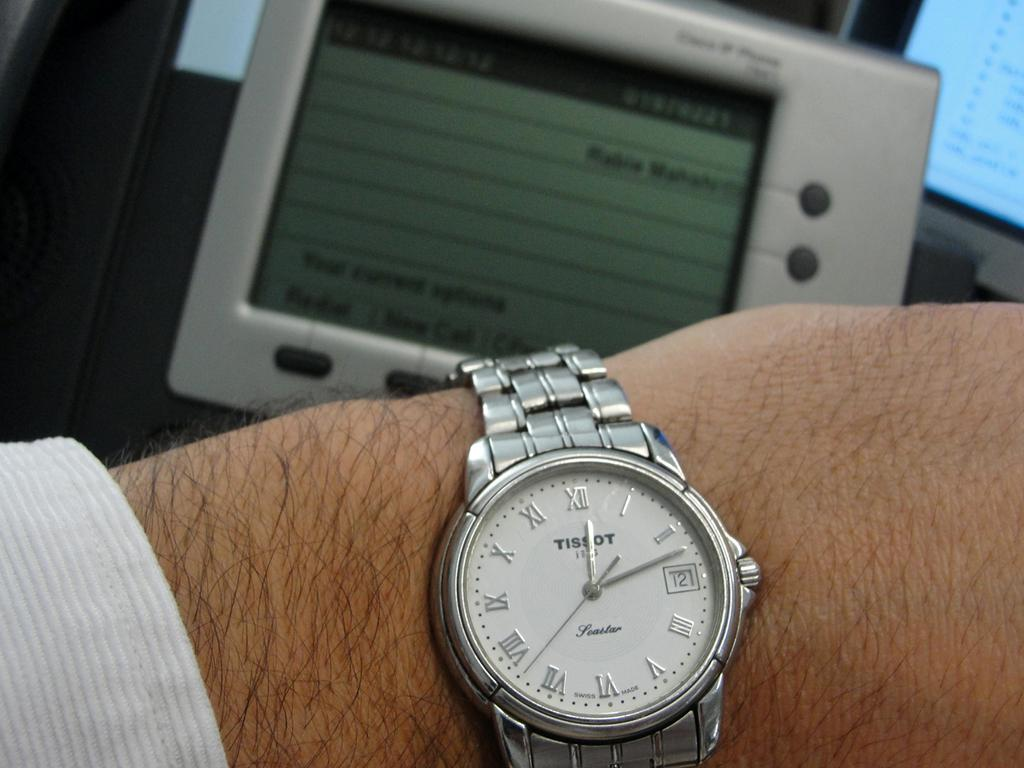<image>
Relay a brief, clear account of the picture shown. A mam wearing a silver with white dial Tissot wrist watch. 